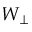Convert formula to latex. <formula><loc_0><loc_0><loc_500><loc_500>W _ { \perp }</formula> 